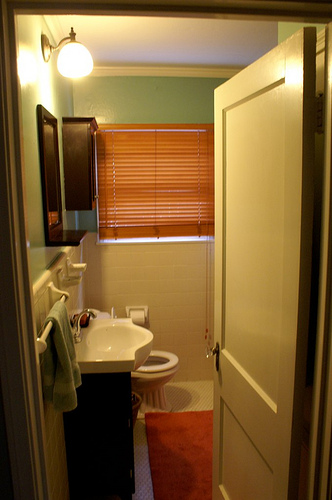Is there any item for personal hygiene next to the toilet? Yes, to the left of the toilet, there is a roll of toilet tissue, ensuring users have essential hygiene items within reach. 